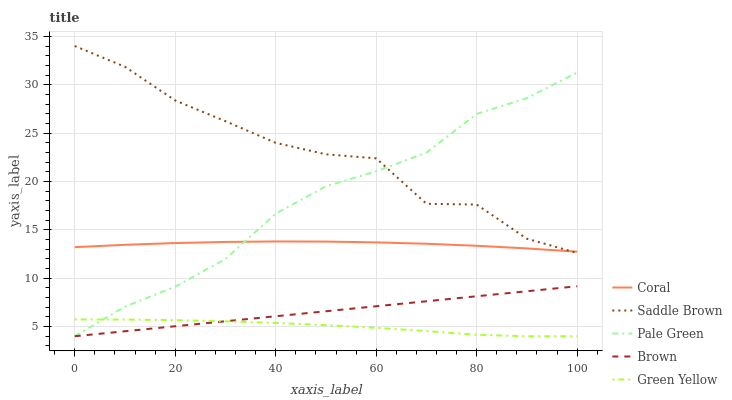Does Green Yellow have the minimum area under the curve?
Answer yes or no. Yes. Does Saddle Brown have the maximum area under the curve?
Answer yes or no. Yes. Does Brown have the minimum area under the curve?
Answer yes or no. No. Does Brown have the maximum area under the curve?
Answer yes or no. No. Is Brown the smoothest?
Answer yes or no. Yes. Is Saddle Brown the roughest?
Answer yes or no. Yes. Is Coral the smoothest?
Answer yes or no. No. Is Coral the roughest?
Answer yes or no. No. Does Green Yellow have the lowest value?
Answer yes or no. Yes. Does Coral have the lowest value?
Answer yes or no. No. Does Saddle Brown have the highest value?
Answer yes or no. Yes. Does Brown have the highest value?
Answer yes or no. No. Is Green Yellow less than Coral?
Answer yes or no. Yes. Is Coral greater than Brown?
Answer yes or no. Yes. Does Pale Green intersect Brown?
Answer yes or no. Yes. Is Pale Green less than Brown?
Answer yes or no. No. Is Pale Green greater than Brown?
Answer yes or no. No. Does Green Yellow intersect Coral?
Answer yes or no. No. 